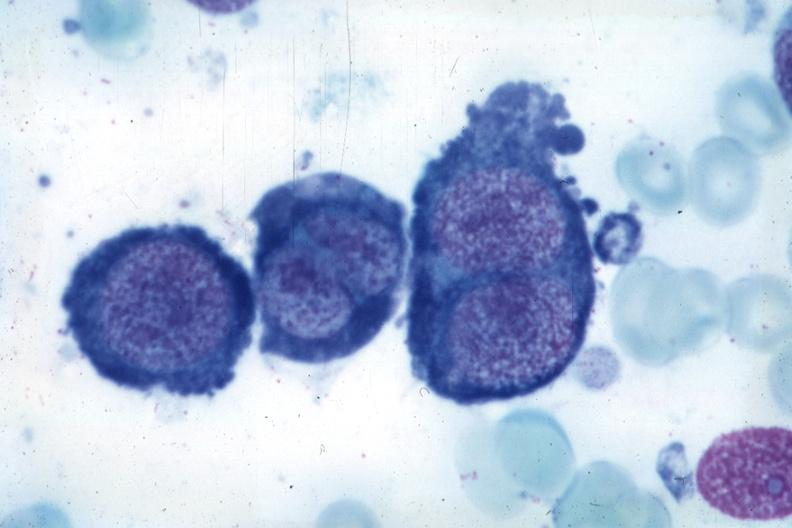what does this image show?
Answer the question using a single word or phrase. Wrights typical cells 